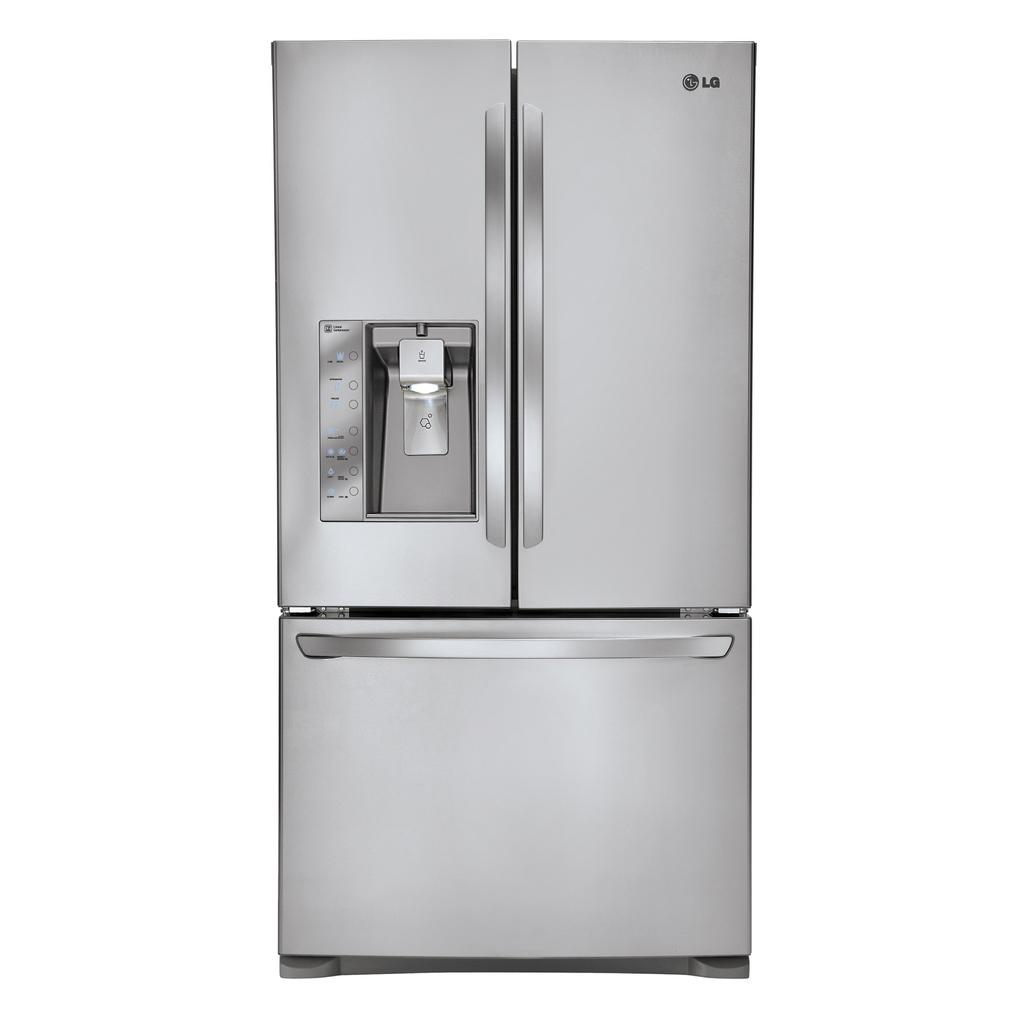What type of appliance can be seen in the image? There is a refrigerator in the image. What type of laborer is working on the refrigerator in the image? There is no laborer present in the image, and the refrigerator is not being worked on. 